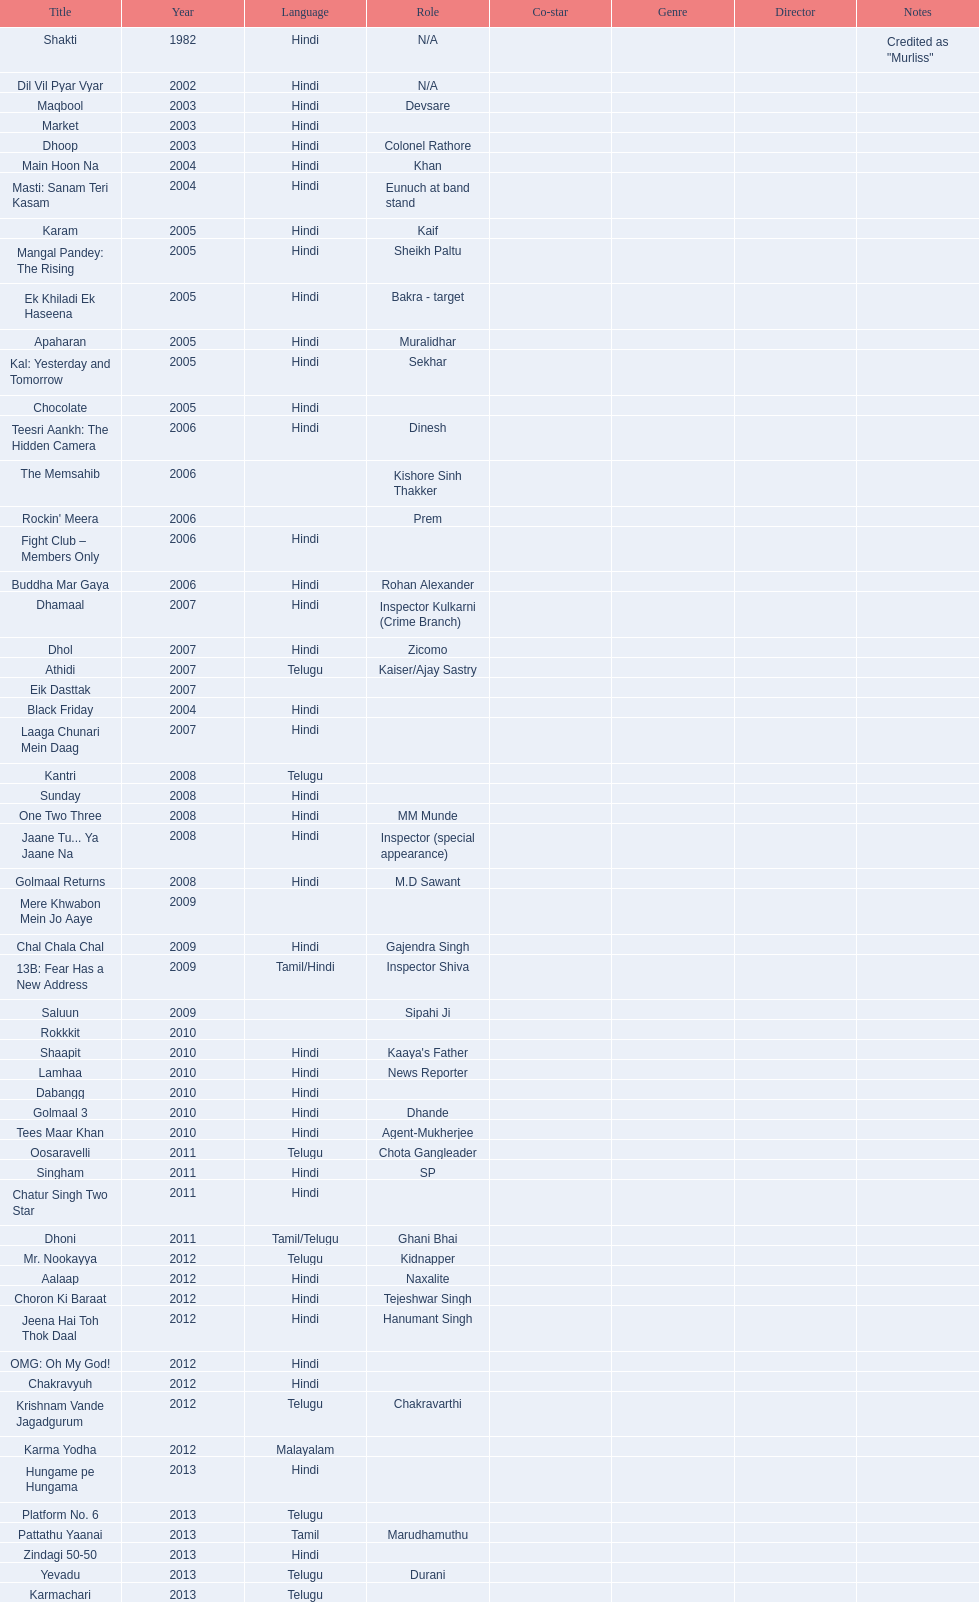What is the first language after hindi Telugu. 